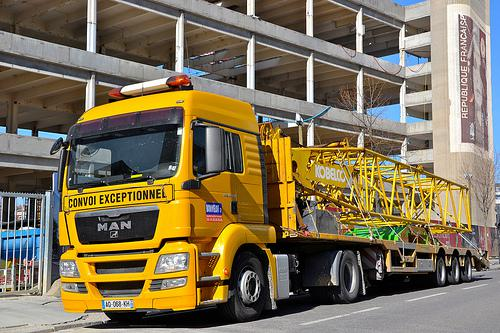Question: why was the picture taken?
Choices:
A. To memorialize the occasion.
B. To see the animals.
C. To show how the dog looks.
D. To capture the truck.
Answer with the letter. Answer: D Question: where was the picture taken?
Choices:
A. On a beach.
B. On the road.
C. At a zoo.
D. In a school.
Answer with the letter. Answer: B 